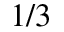Convert formula to latex. <formula><loc_0><loc_0><loc_500><loc_500>1 / 3</formula> 